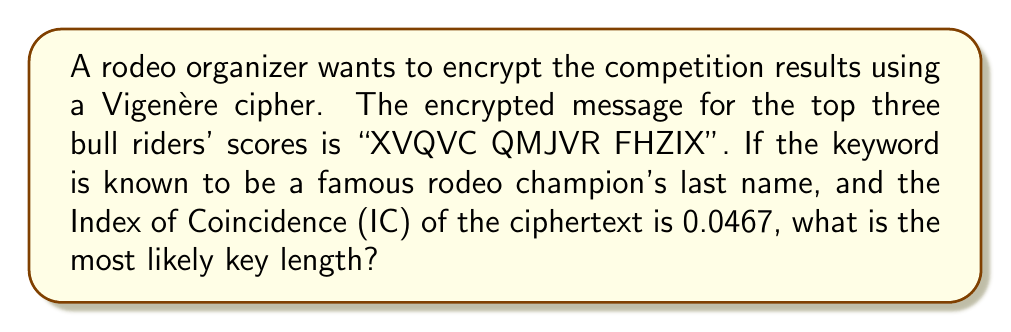Can you solve this math problem? To determine the most likely key length for a Vigenère cipher, we can use the Index of Coincidence (IC). The steps are as follows:

1. The given IC of the ciphertext is 0.0467.

2. For English plaintext, the expected IC is approximately 0.0667.

3. For a Vigenère cipher with key length $L$, the expected IC is:

   $$ IC_{expected} = \frac{0.0667}{L} + \frac{L-1}{L} \cdot 0.0385 $$

   where 0.0385 is the IC for a random text.

4. We can set up an equation:

   $$ 0.0467 = \frac{0.0667}{L} + \frac{L-1}{L} \cdot 0.0385 $$

5. Solving for $L$:

   $$ 0.0467L = 0.0667 + 0.0385L - 0.0385 $$
   $$ 0.0082L = 0.0282 $$
   $$ L = \frac{0.0282}{0.0082} \approx 3.44 $$

6. Since the key length must be an integer, we round to the nearest whole number.

7. The most likely key length is 3, which is consistent with using a famous rodeo champion's last name as the keyword (e.g., "Tuf" for Tuf Cooper).
Answer: 3 